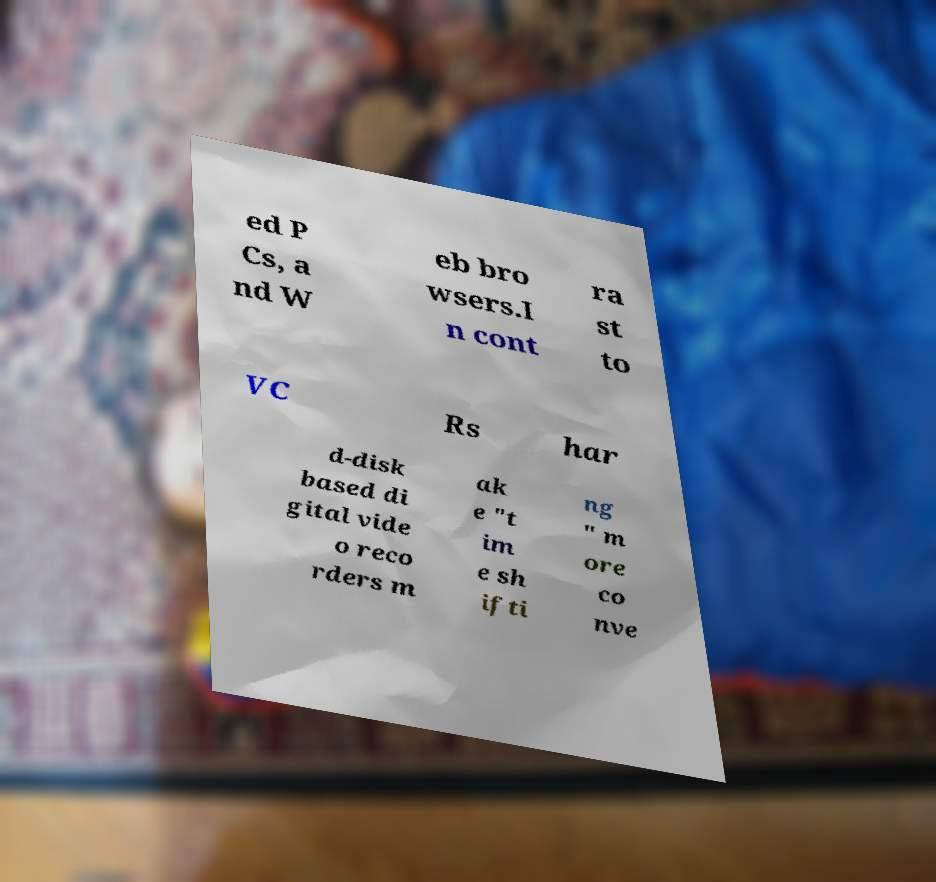Could you assist in decoding the text presented in this image and type it out clearly? ed P Cs, a nd W eb bro wsers.I n cont ra st to VC Rs har d-disk based di gital vide o reco rders m ak e "t im e sh ifti ng " m ore co nve 